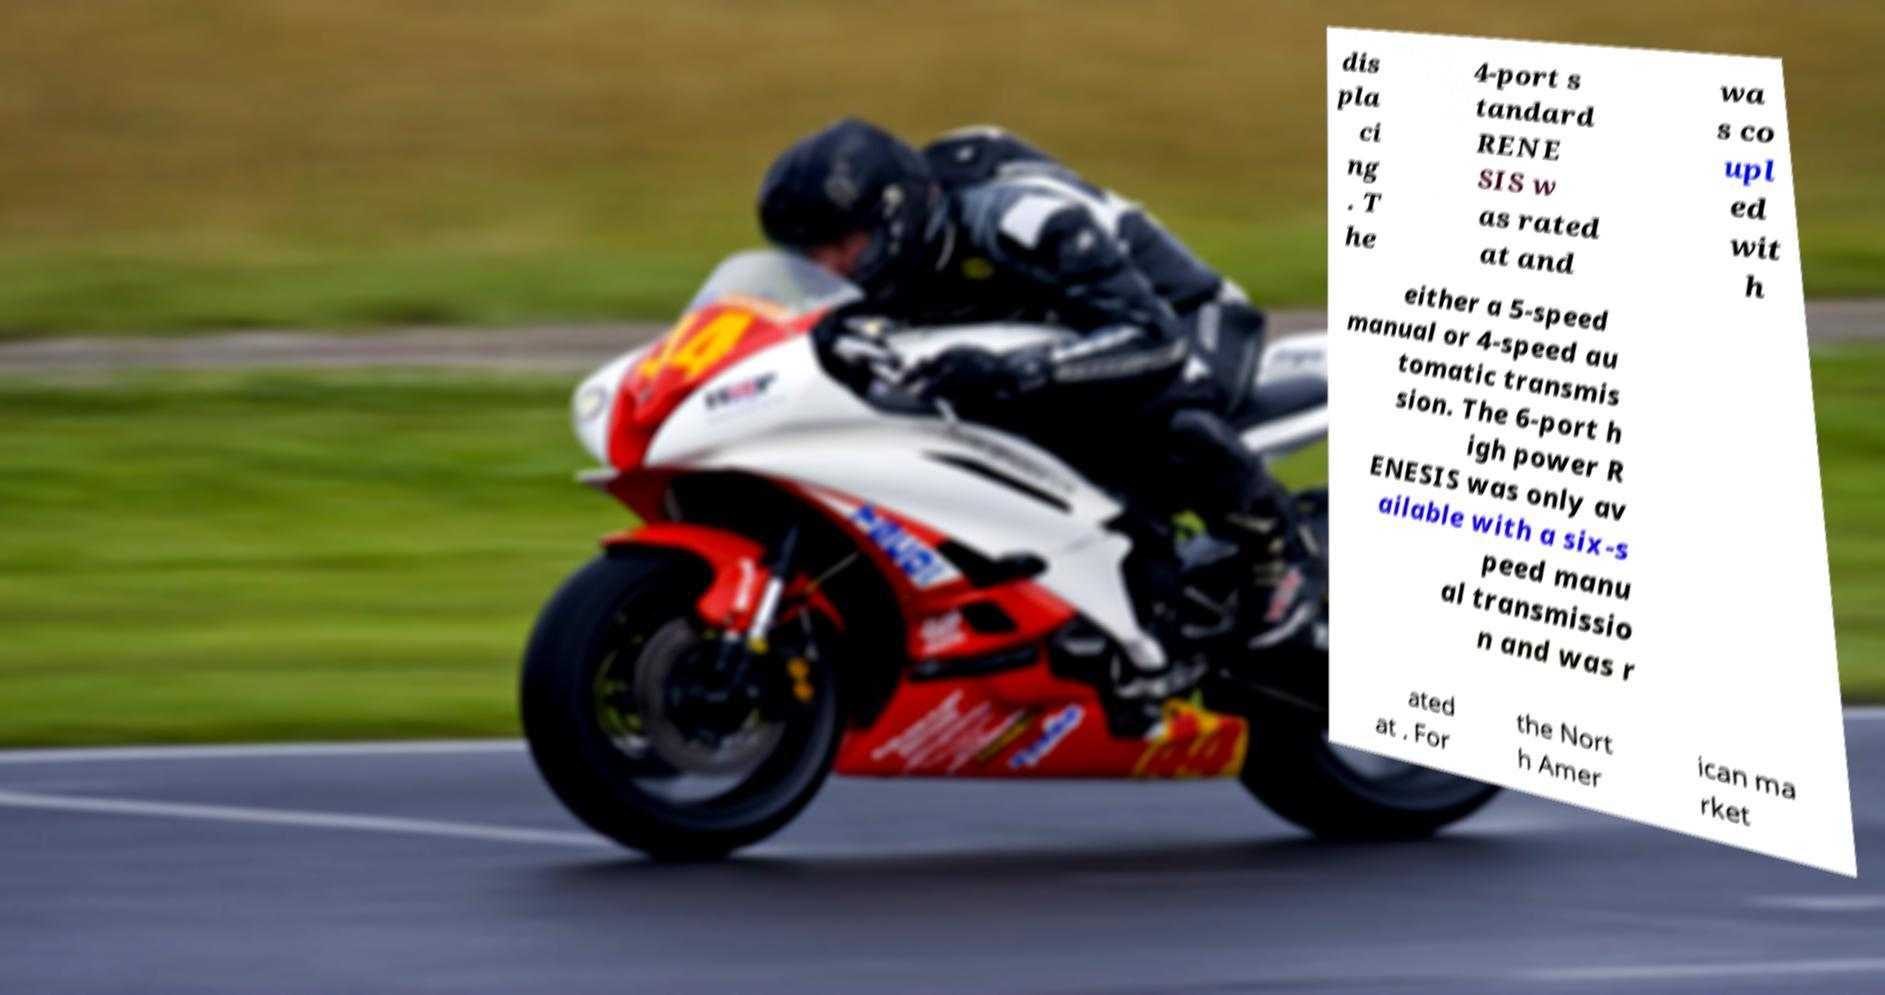Please read and relay the text visible in this image. What does it say? dis pla ci ng . T he 4-port s tandard RENE SIS w as rated at and wa s co upl ed wit h either a 5-speed manual or 4-speed au tomatic transmis sion. The 6-port h igh power R ENESIS was only av ailable with a six-s peed manu al transmissio n and was r ated at . For the Nort h Amer ican ma rket 